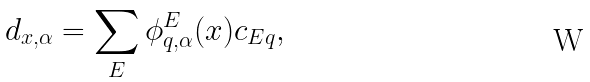<formula> <loc_0><loc_0><loc_500><loc_500>d _ { { x } , \alpha } = \sum _ { E } \phi ^ { E } _ { q , \alpha } ( { x } ) c _ { E q } ,</formula> 